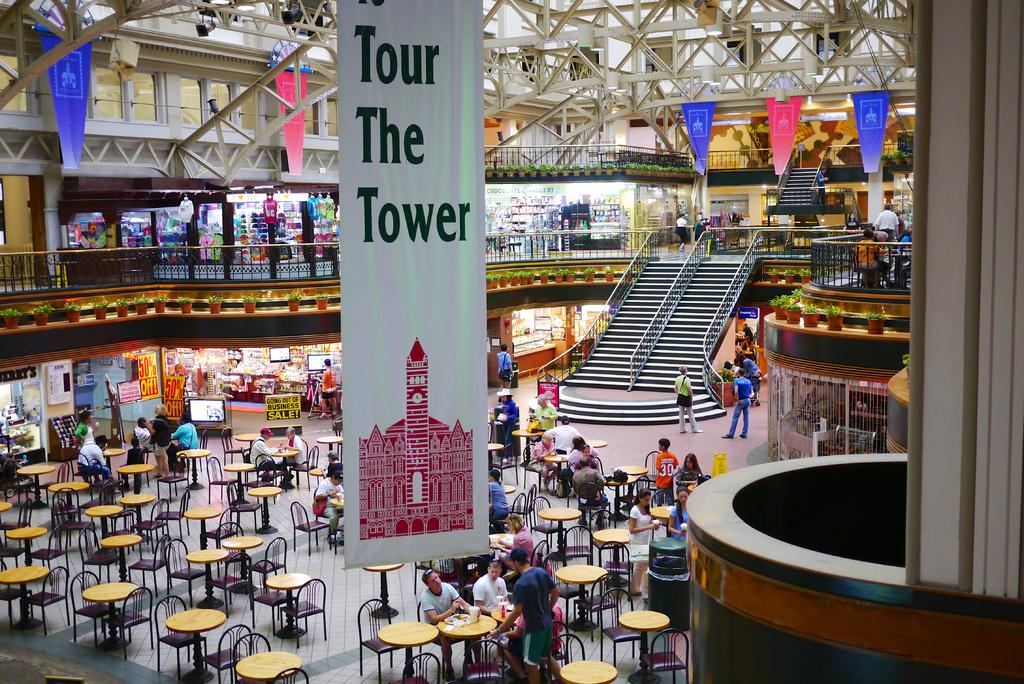<image>
Relay a brief, clear account of the picture shown. A banner that says "Tour The Tower" hangs from the mall's ceiling 